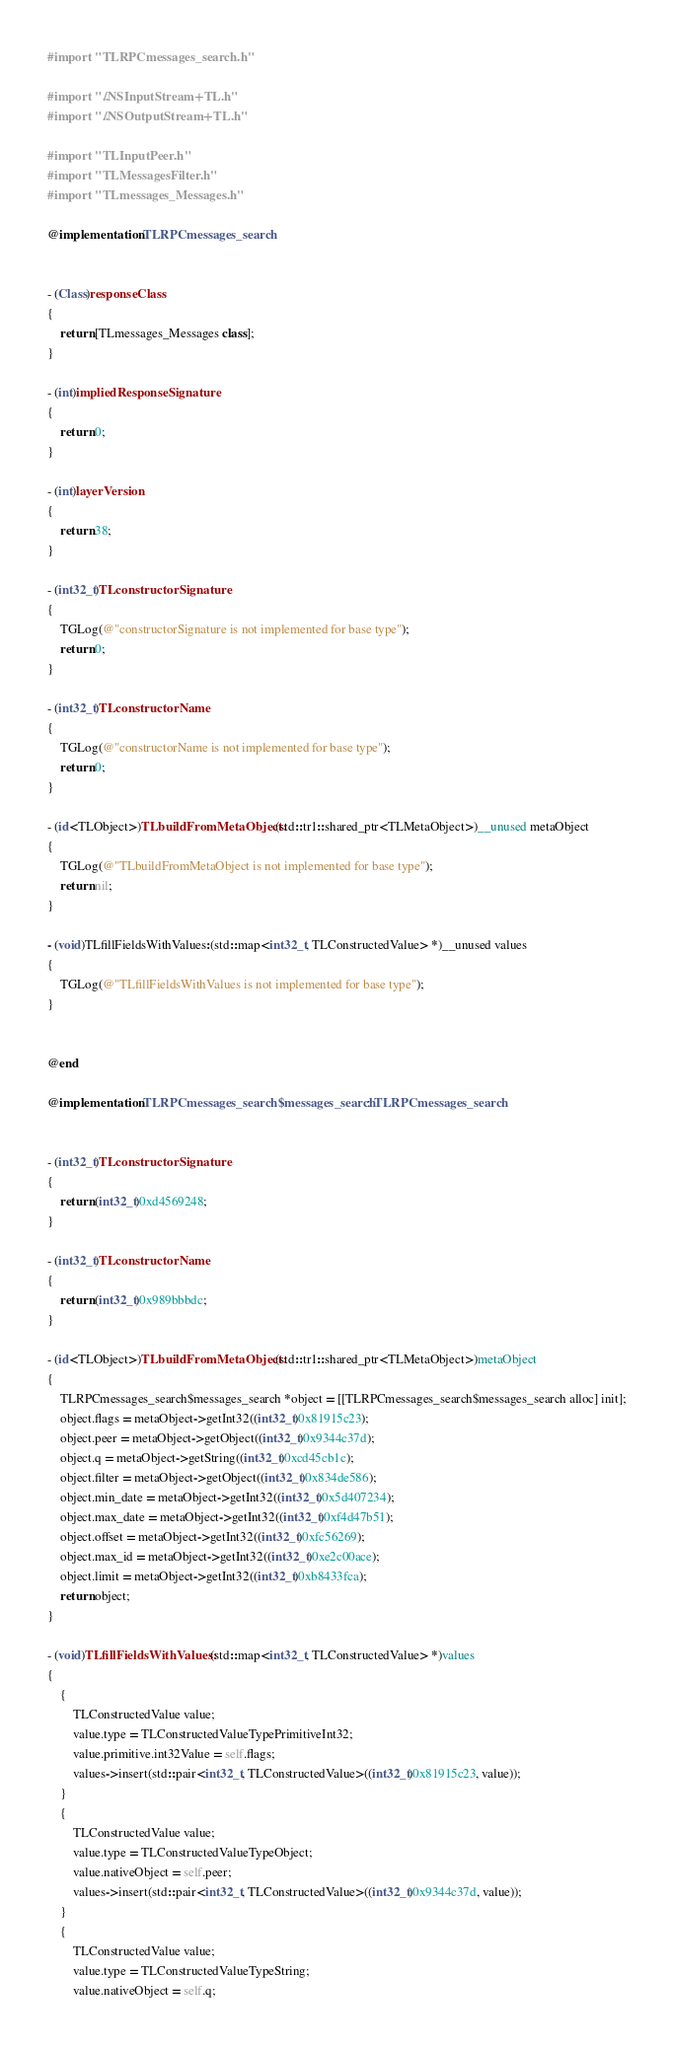<code> <loc_0><loc_0><loc_500><loc_500><_ObjectiveC_>#import "TLRPCmessages_search.h"

#import "../NSInputStream+TL.h"
#import "../NSOutputStream+TL.h"

#import "TLInputPeer.h"
#import "TLMessagesFilter.h"
#import "TLmessages_Messages.h"

@implementation TLRPCmessages_search


- (Class)responseClass
{
    return [TLmessages_Messages class];
}

- (int)impliedResponseSignature
{
    return 0;
}

- (int)layerVersion
{
    return 38;
}

- (int32_t)TLconstructorSignature
{
    TGLog(@"constructorSignature is not implemented for base type");
    return 0;
}

- (int32_t)TLconstructorName
{
    TGLog(@"constructorName is not implemented for base type");
    return 0;
}

- (id<TLObject>)TLbuildFromMetaObject:(std::tr1::shared_ptr<TLMetaObject>)__unused metaObject
{
    TGLog(@"TLbuildFromMetaObject is not implemented for base type");
    return nil;
}

- (void)TLfillFieldsWithValues:(std::map<int32_t, TLConstructedValue> *)__unused values
{
    TGLog(@"TLfillFieldsWithValues is not implemented for base type");
}


@end

@implementation TLRPCmessages_search$messages_search : TLRPCmessages_search


- (int32_t)TLconstructorSignature
{
    return (int32_t)0xd4569248;
}

- (int32_t)TLconstructorName
{
    return (int32_t)0x989bbbdc;
}

- (id<TLObject>)TLbuildFromMetaObject:(std::tr1::shared_ptr<TLMetaObject>)metaObject
{
    TLRPCmessages_search$messages_search *object = [[TLRPCmessages_search$messages_search alloc] init];
    object.flags = metaObject->getInt32((int32_t)0x81915c23);
    object.peer = metaObject->getObject((int32_t)0x9344c37d);
    object.q = metaObject->getString((int32_t)0xcd45cb1c);
    object.filter = metaObject->getObject((int32_t)0x834de586);
    object.min_date = metaObject->getInt32((int32_t)0x5d407234);
    object.max_date = metaObject->getInt32((int32_t)0xf4d47b51);
    object.offset = metaObject->getInt32((int32_t)0xfc56269);
    object.max_id = metaObject->getInt32((int32_t)0xe2c00ace);
    object.limit = metaObject->getInt32((int32_t)0xb8433fca);
    return object;
}

- (void)TLfillFieldsWithValues:(std::map<int32_t, TLConstructedValue> *)values
{
    {
        TLConstructedValue value;
        value.type = TLConstructedValueTypePrimitiveInt32;
        value.primitive.int32Value = self.flags;
        values->insert(std::pair<int32_t, TLConstructedValue>((int32_t)0x81915c23, value));
    }
    {
        TLConstructedValue value;
        value.type = TLConstructedValueTypeObject;
        value.nativeObject = self.peer;
        values->insert(std::pair<int32_t, TLConstructedValue>((int32_t)0x9344c37d, value));
    }
    {
        TLConstructedValue value;
        value.type = TLConstructedValueTypeString;
        value.nativeObject = self.q;</code> 